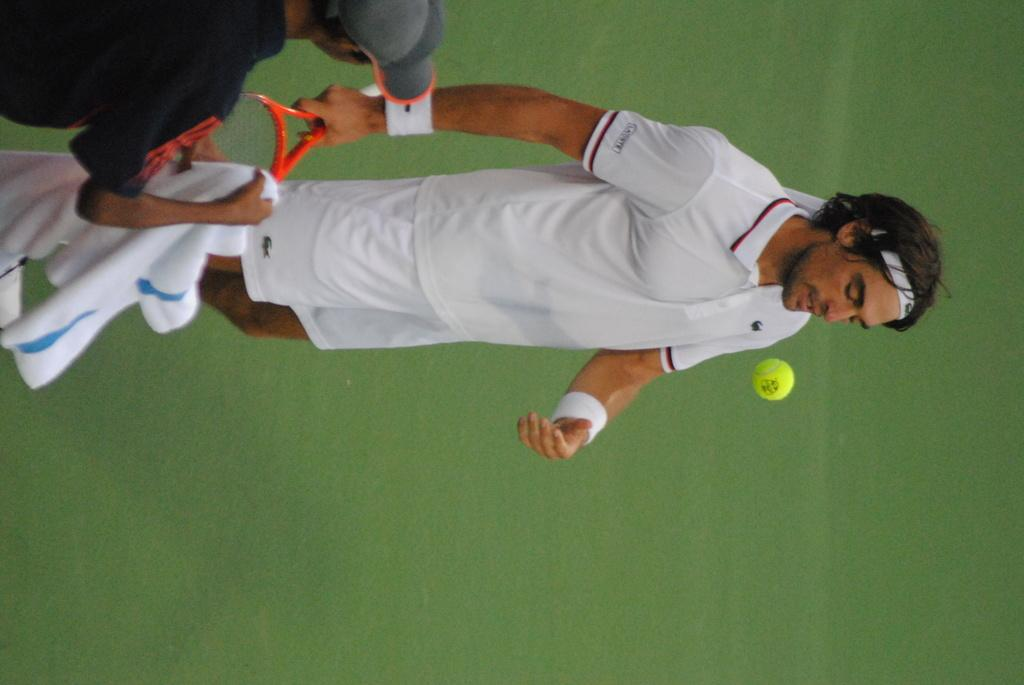What is the man in the image doing? The man is standing on the ground in the image. What is the man wearing? The man is wearing a white shirt. What object is the man holding in his hands? The man is holding a racket in his hands. Can you identify another person in the image? Yes, there is a person standing in the image. What else can be seen in the image? There is a ball visible in the image. What degree of difficulty does the cloud in the image present for the man? There is no cloud present in the image, so this question cannot be answered. 